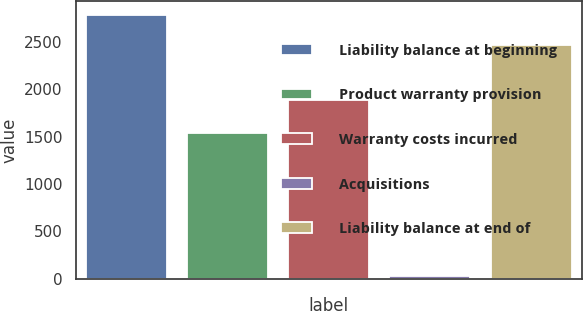Convert chart to OTSL. <chart><loc_0><loc_0><loc_500><loc_500><bar_chart><fcel>Liability balance at beginning<fcel>Product warranty provision<fcel>Warranty costs incurred<fcel>Acquisitions<fcel>Liability balance at end of<nl><fcel>2789<fcel>1541<fcel>1890<fcel>32<fcel>2472<nl></chart> 